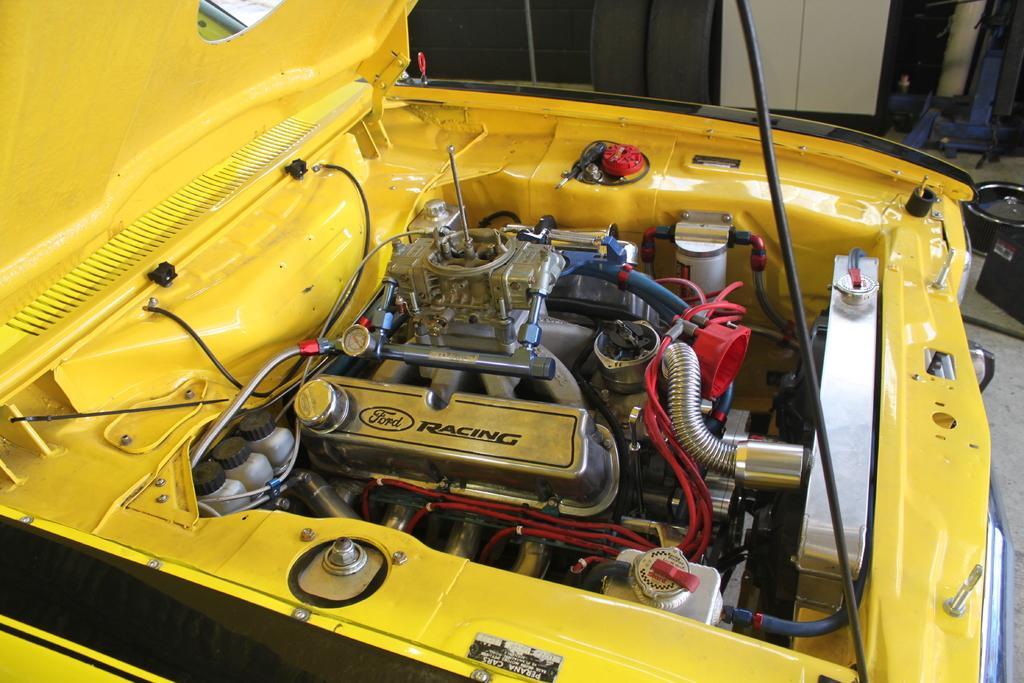Can you describe this image briefly? In this image we can see the yellow color car bonnet. In the background, we can see some objects on the floor. 